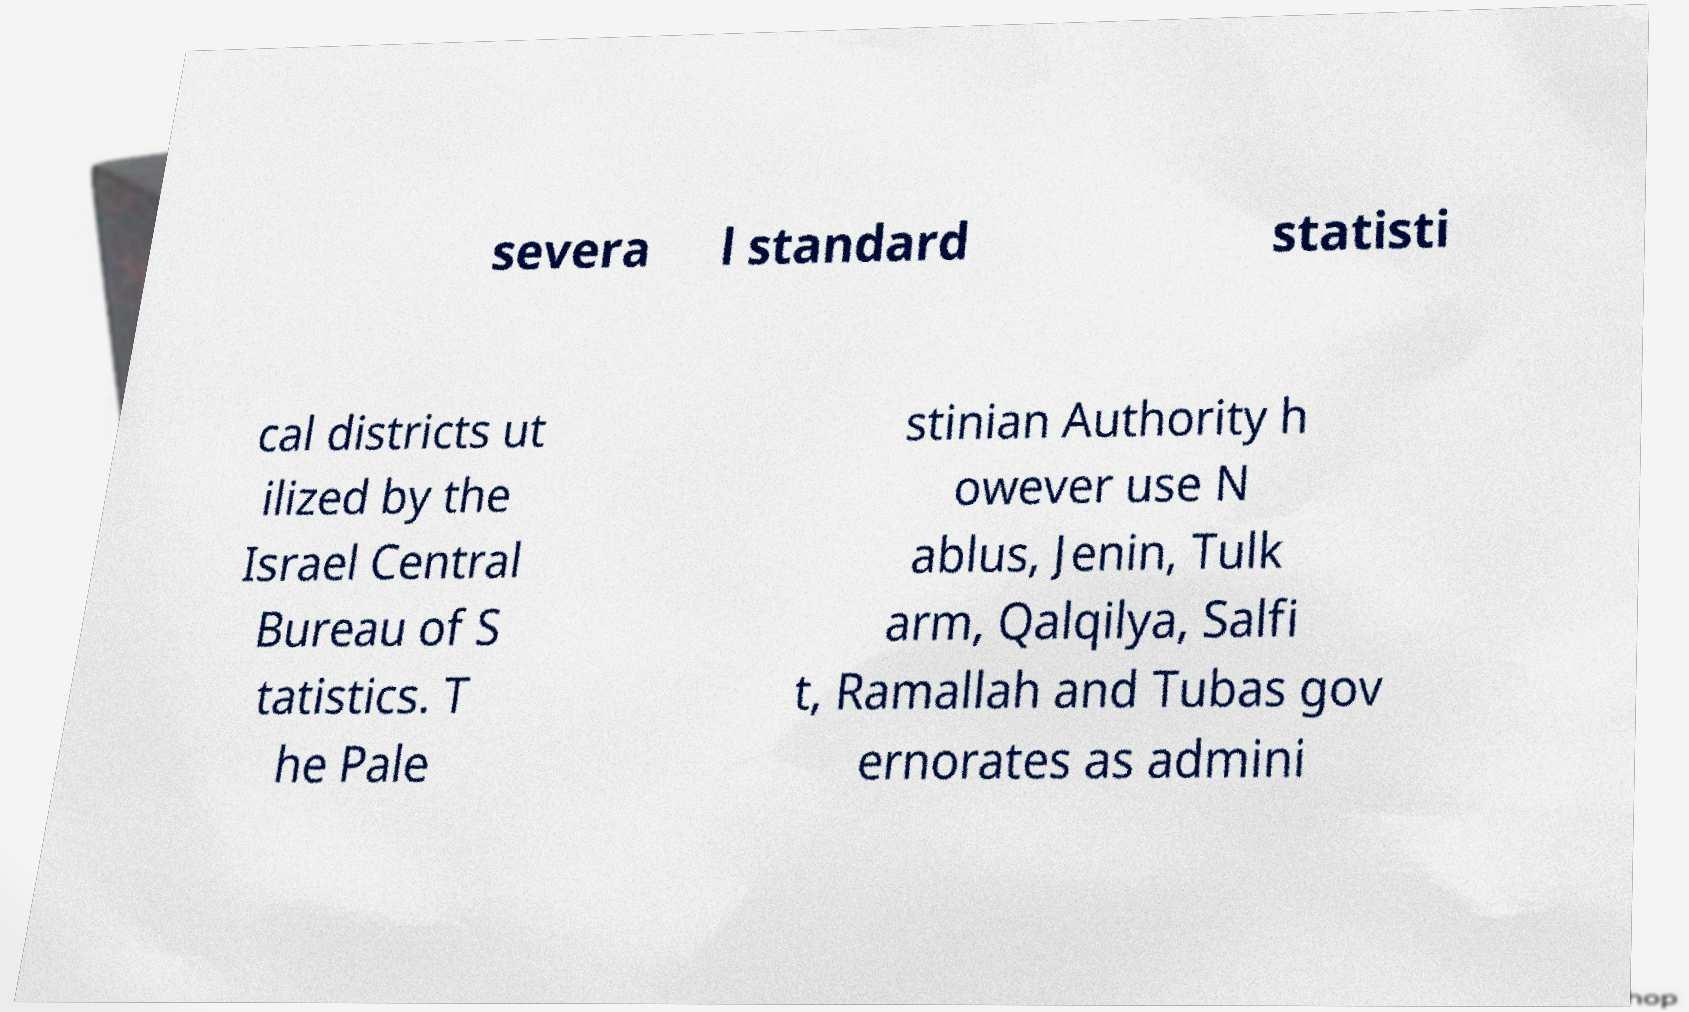For documentation purposes, I need the text within this image transcribed. Could you provide that? severa l standard statisti cal districts ut ilized by the Israel Central Bureau of S tatistics. T he Pale stinian Authority h owever use N ablus, Jenin, Tulk arm, Qalqilya, Salfi t, Ramallah and Tubas gov ernorates as admini 